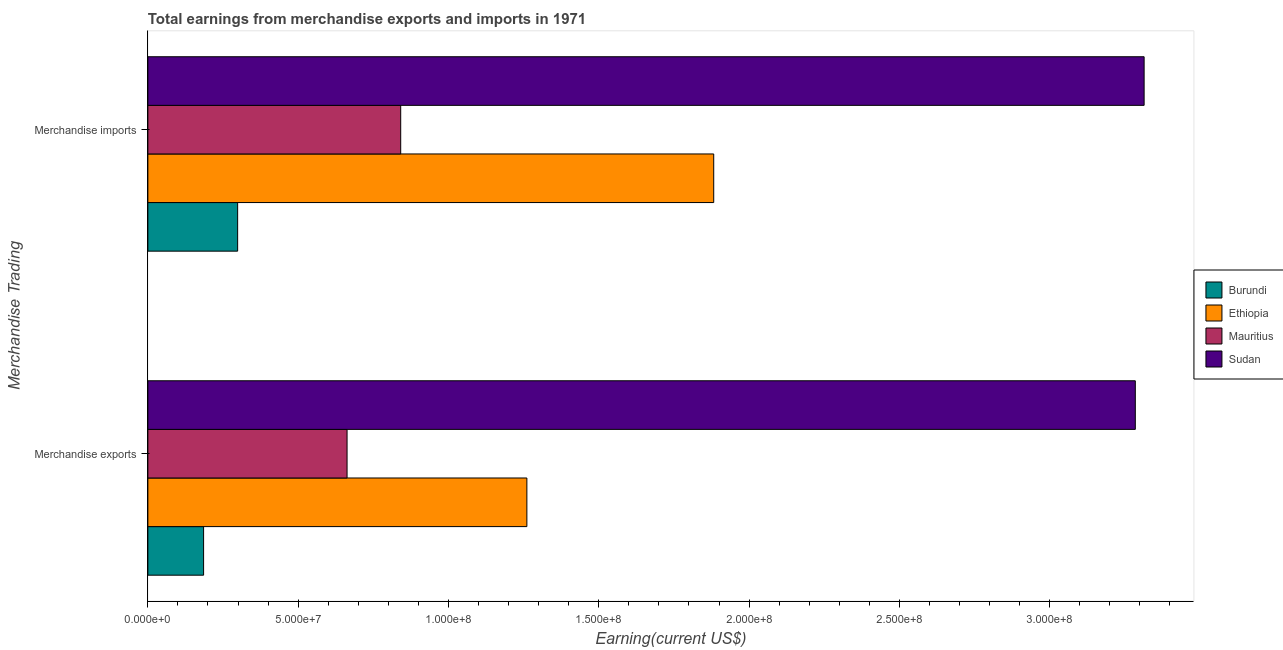How many different coloured bars are there?
Ensure brevity in your answer.  4. Are the number of bars on each tick of the Y-axis equal?
Offer a terse response. Yes. What is the earnings from merchandise imports in Burundi?
Give a very brief answer. 2.99e+07. Across all countries, what is the maximum earnings from merchandise exports?
Provide a short and direct response. 3.28e+08. Across all countries, what is the minimum earnings from merchandise imports?
Provide a short and direct response. 2.99e+07. In which country was the earnings from merchandise exports maximum?
Offer a very short reply. Sudan. In which country was the earnings from merchandise exports minimum?
Your response must be concise. Burundi. What is the total earnings from merchandise exports in the graph?
Your answer should be compact. 5.39e+08. What is the difference between the earnings from merchandise exports in Burundi and that in Sudan?
Your response must be concise. -3.10e+08. What is the difference between the earnings from merchandise imports in Ethiopia and the earnings from merchandise exports in Burundi?
Your response must be concise. 1.70e+08. What is the average earnings from merchandise imports per country?
Offer a very short reply. 1.58e+08. What is the difference between the earnings from merchandise imports and earnings from merchandise exports in Mauritius?
Make the answer very short. 1.78e+07. What is the ratio of the earnings from merchandise exports in Sudan to that in Mauritius?
Your response must be concise. 4.96. In how many countries, is the earnings from merchandise exports greater than the average earnings from merchandise exports taken over all countries?
Provide a succinct answer. 1. What does the 2nd bar from the top in Merchandise exports represents?
Provide a short and direct response. Mauritius. What does the 2nd bar from the bottom in Merchandise exports represents?
Your answer should be compact. Ethiopia. How many bars are there?
Your response must be concise. 8. Are all the bars in the graph horizontal?
Make the answer very short. Yes. How many countries are there in the graph?
Give a very brief answer. 4. Where does the legend appear in the graph?
Give a very brief answer. Center right. How many legend labels are there?
Provide a succinct answer. 4. What is the title of the graph?
Your answer should be compact. Total earnings from merchandise exports and imports in 1971. Does "Nicaragua" appear as one of the legend labels in the graph?
Your response must be concise. No. What is the label or title of the X-axis?
Make the answer very short. Earning(current US$). What is the label or title of the Y-axis?
Your response must be concise. Merchandise Trading. What is the Earning(current US$) of Burundi in Merchandise exports?
Offer a very short reply. 1.85e+07. What is the Earning(current US$) of Ethiopia in Merchandise exports?
Ensure brevity in your answer.  1.26e+08. What is the Earning(current US$) in Mauritius in Merchandise exports?
Offer a terse response. 6.63e+07. What is the Earning(current US$) in Sudan in Merchandise exports?
Keep it short and to the point. 3.28e+08. What is the Earning(current US$) in Burundi in Merchandise imports?
Offer a very short reply. 2.99e+07. What is the Earning(current US$) in Ethiopia in Merchandise imports?
Provide a succinct answer. 1.88e+08. What is the Earning(current US$) of Mauritius in Merchandise imports?
Make the answer very short. 8.41e+07. What is the Earning(current US$) in Sudan in Merchandise imports?
Provide a short and direct response. 3.31e+08. Across all Merchandise Trading, what is the maximum Earning(current US$) in Burundi?
Your answer should be very brief. 2.99e+07. Across all Merchandise Trading, what is the maximum Earning(current US$) in Ethiopia?
Provide a short and direct response. 1.88e+08. Across all Merchandise Trading, what is the maximum Earning(current US$) in Mauritius?
Make the answer very short. 8.41e+07. Across all Merchandise Trading, what is the maximum Earning(current US$) of Sudan?
Provide a short and direct response. 3.31e+08. Across all Merchandise Trading, what is the minimum Earning(current US$) in Burundi?
Provide a succinct answer. 1.85e+07. Across all Merchandise Trading, what is the minimum Earning(current US$) in Ethiopia?
Your response must be concise. 1.26e+08. Across all Merchandise Trading, what is the minimum Earning(current US$) of Mauritius?
Offer a terse response. 6.63e+07. Across all Merchandise Trading, what is the minimum Earning(current US$) in Sudan?
Provide a short and direct response. 3.28e+08. What is the total Earning(current US$) in Burundi in the graph?
Your answer should be compact. 4.84e+07. What is the total Earning(current US$) in Ethiopia in the graph?
Offer a very short reply. 3.14e+08. What is the total Earning(current US$) of Mauritius in the graph?
Offer a very short reply. 1.50e+08. What is the total Earning(current US$) of Sudan in the graph?
Keep it short and to the point. 6.60e+08. What is the difference between the Earning(current US$) of Burundi in Merchandise exports and that in Merchandise imports?
Keep it short and to the point. -1.13e+07. What is the difference between the Earning(current US$) in Ethiopia in Merchandise exports and that in Merchandise imports?
Ensure brevity in your answer.  -6.22e+07. What is the difference between the Earning(current US$) in Mauritius in Merchandise exports and that in Merchandise imports?
Offer a terse response. -1.78e+07. What is the difference between the Earning(current US$) of Sudan in Merchandise exports and that in Merchandise imports?
Provide a succinct answer. -2.93e+06. What is the difference between the Earning(current US$) of Burundi in Merchandise exports and the Earning(current US$) of Ethiopia in Merchandise imports?
Provide a short and direct response. -1.70e+08. What is the difference between the Earning(current US$) in Burundi in Merchandise exports and the Earning(current US$) in Mauritius in Merchandise imports?
Your answer should be very brief. -6.56e+07. What is the difference between the Earning(current US$) in Burundi in Merchandise exports and the Earning(current US$) in Sudan in Merchandise imports?
Make the answer very short. -3.13e+08. What is the difference between the Earning(current US$) in Ethiopia in Merchandise exports and the Earning(current US$) in Mauritius in Merchandise imports?
Make the answer very short. 4.20e+07. What is the difference between the Earning(current US$) of Ethiopia in Merchandise exports and the Earning(current US$) of Sudan in Merchandise imports?
Your response must be concise. -2.05e+08. What is the difference between the Earning(current US$) of Mauritius in Merchandise exports and the Earning(current US$) of Sudan in Merchandise imports?
Your response must be concise. -2.65e+08. What is the average Earning(current US$) in Burundi per Merchandise Trading?
Provide a short and direct response. 2.42e+07. What is the average Earning(current US$) of Ethiopia per Merchandise Trading?
Your response must be concise. 1.57e+08. What is the average Earning(current US$) of Mauritius per Merchandise Trading?
Make the answer very short. 7.52e+07. What is the average Earning(current US$) of Sudan per Merchandise Trading?
Give a very brief answer. 3.30e+08. What is the difference between the Earning(current US$) of Burundi and Earning(current US$) of Ethiopia in Merchandise exports?
Your answer should be compact. -1.08e+08. What is the difference between the Earning(current US$) of Burundi and Earning(current US$) of Mauritius in Merchandise exports?
Your answer should be compact. -4.77e+07. What is the difference between the Earning(current US$) in Burundi and Earning(current US$) in Sudan in Merchandise exports?
Offer a very short reply. -3.10e+08. What is the difference between the Earning(current US$) in Ethiopia and Earning(current US$) in Mauritius in Merchandise exports?
Make the answer very short. 5.98e+07. What is the difference between the Earning(current US$) of Ethiopia and Earning(current US$) of Sudan in Merchandise exports?
Your answer should be compact. -2.02e+08. What is the difference between the Earning(current US$) of Mauritius and Earning(current US$) of Sudan in Merchandise exports?
Give a very brief answer. -2.62e+08. What is the difference between the Earning(current US$) in Burundi and Earning(current US$) in Ethiopia in Merchandise imports?
Offer a terse response. -1.58e+08. What is the difference between the Earning(current US$) of Burundi and Earning(current US$) of Mauritius in Merchandise imports?
Make the answer very short. -5.42e+07. What is the difference between the Earning(current US$) in Burundi and Earning(current US$) in Sudan in Merchandise imports?
Provide a succinct answer. -3.02e+08. What is the difference between the Earning(current US$) in Ethiopia and Earning(current US$) in Mauritius in Merchandise imports?
Offer a terse response. 1.04e+08. What is the difference between the Earning(current US$) in Ethiopia and Earning(current US$) in Sudan in Merchandise imports?
Ensure brevity in your answer.  -1.43e+08. What is the difference between the Earning(current US$) in Mauritius and Earning(current US$) in Sudan in Merchandise imports?
Give a very brief answer. -2.47e+08. What is the ratio of the Earning(current US$) in Burundi in Merchandise exports to that in Merchandise imports?
Offer a very short reply. 0.62. What is the ratio of the Earning(current US$) of Ethiopia in Merchandise exports to that in Merchandise imports?
Your answer should be compact. 0.67. What is the ratio of the Earning(current US$) of Mauritius in Merchandise exports to that in Merchandise imports?
Provide a succinct answer. 0.79. What is the ratio of the Earning(current US$) of Sudan in Merchandise exports to that in Merchandise imports?
Your answer should be very brief. 0.99. What is the difference between the highest and the second highest Earning(current US$) of Burundi?
Provide a succinct answer. 1.13e+07. What is the difference between the highest and the second highest Earning(current US$) of Ethiopia?
Give a very brief answer. 6.22e+07. What is the difference between the highest and the second highest Earning(current US$) of Mauritius?
Keep it short and to the point. 1.78e+07. What is the difference between the highest and the second highest Earning(current US$) of Sudan?
Give a very brief answer. 2.93e+06. What is the difference between the highest and the lowest Earning(current US$) in Burundi?
Offer a terse response. 1.13e+07. What is the difference between the highest and the lowest Earning(current US$) of Ethiopia?
Ensure brevity in your answer.  6.22e+07. What is the difference between the highest and the lowest Earning(current US$) of Mauritius?
Provide a short and direct response. 1.78e+07. What is the difference between the highest and the lowest Earning(current US$) in Sudan?
Give a very brief answer. 2.93e+06. 